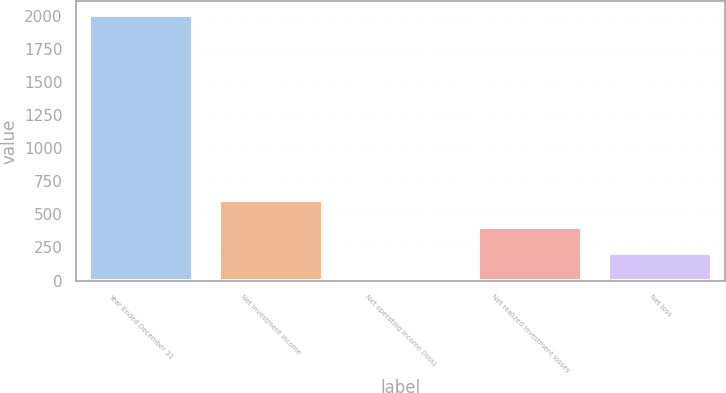<chart> <loc_0><loc_0><loc_500><loc_500><bar_chart><fcel>Year Ended December 31<fcel>Net investment income<fcel>Net operating income (loss)<fcel>Net realized investment losses<fcel>Net loss<nl><fcel>2007<fcel>605.6<fcel>5<fcel>405.4<fcel>205.2<nl></chart> 